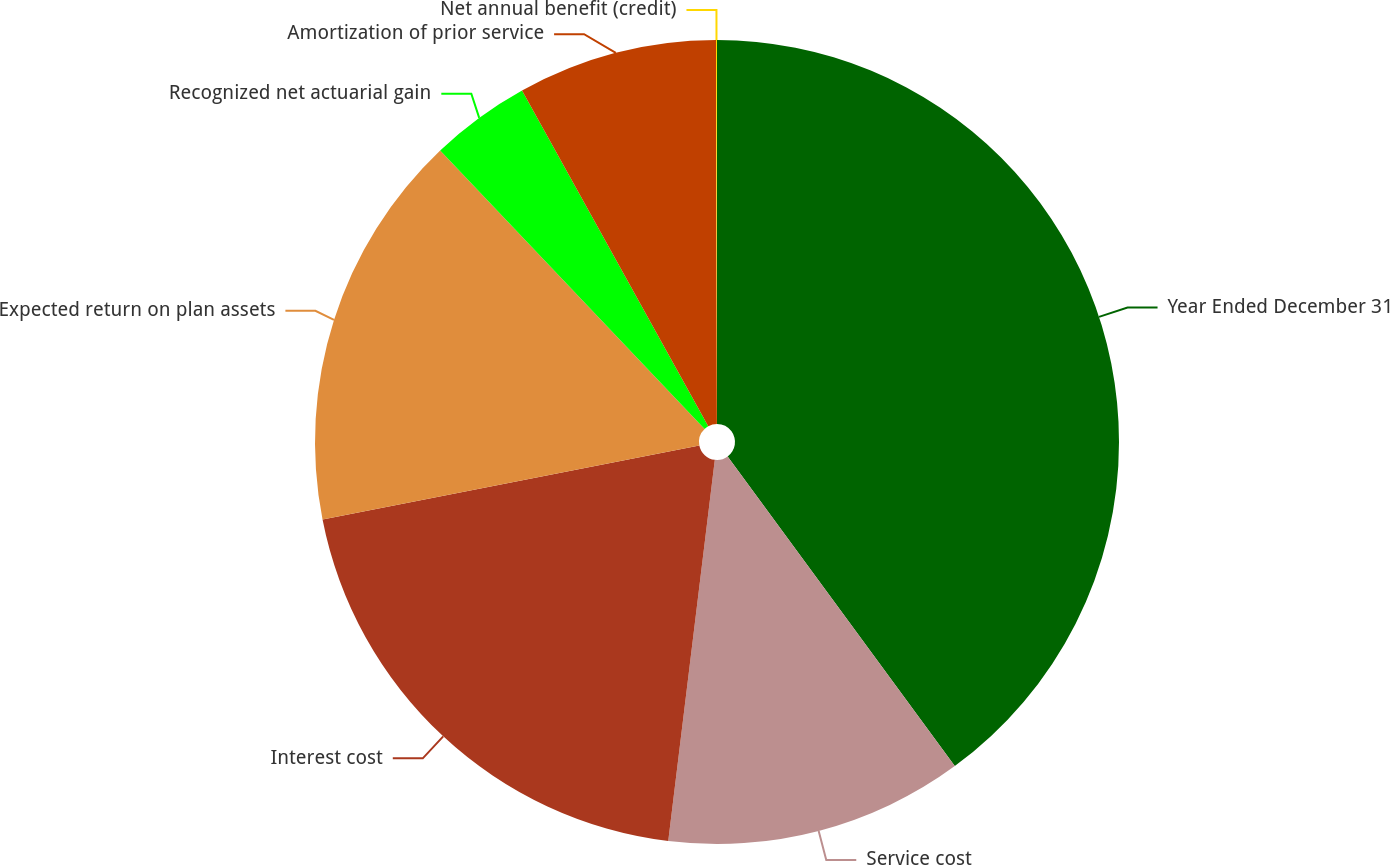<chart> <loc_0><loc_0><loc_500><loc_500><pie_chart><fcel>Year Ended December 31<fcel>Service cost<fcel>Interest cost<fcel>Expected return on plan assets<fcel>Recognized net actuarial gain<fcel>Amortization of prior service<fcel>Net annual benefit (credit)<nl><fcel>39.93%<fcel>12.01%<fcel>19.98%<fcel>16.0%<fcel>4.03%<fcel>8.02%<fcel>0.04%<nl></chart> 